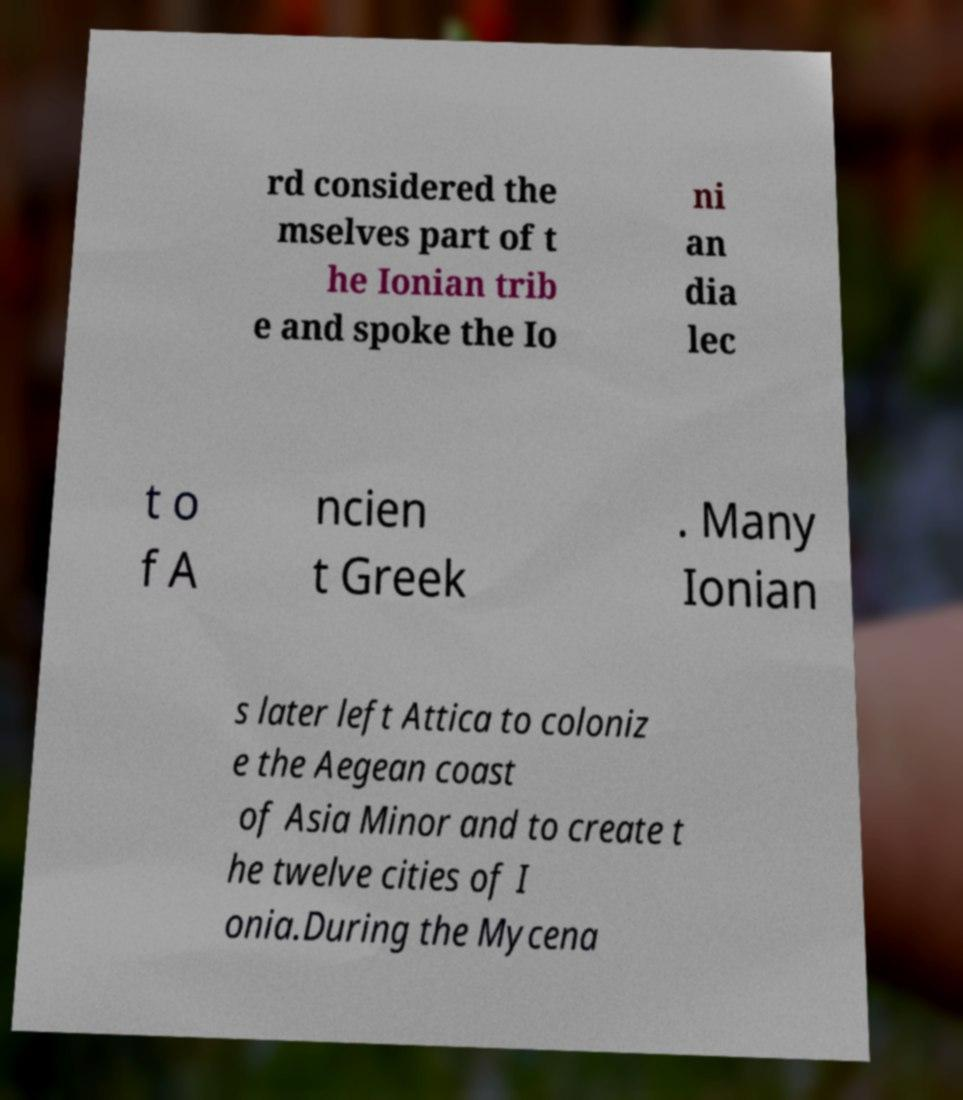I need the written content from this picture converted into text. Can you do that? rd considered the mselves part of t he Ionian trib e and spoke the Io ni an dia lec t o f A ncien t Greek . Many Ionian s later left Attica to coloniz e the Aegean coast of Asia Minor and to create t he twelve cities of I onia.During the Mycena 